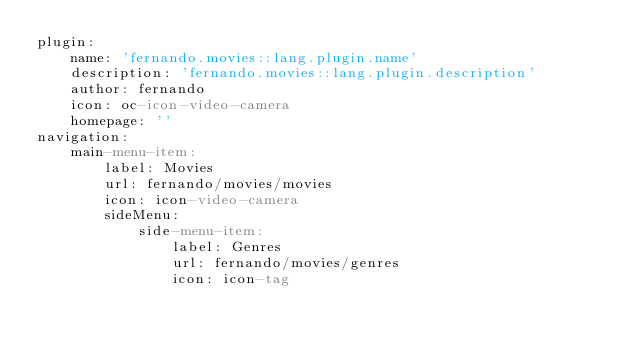<code> <loc_0><loc_0><loc_500><loc_500><_YAML_>plugin:
    name: 'fernando.movies::lang.plugin.name'
    description: 'fernando.movies::lang.plugin.description'
    author: fernando
    icon: oc-icon-video-camera
    homepage: ''
navigation:
    main-menu-item:
        label: Movies
        url: fernando/movies/movies
        icon: icon-video-camera
        sideMenu:
            side-menu-item:
                label: Genres
                url: fernando/movies/genres
                icon: icon-tag
</code> 